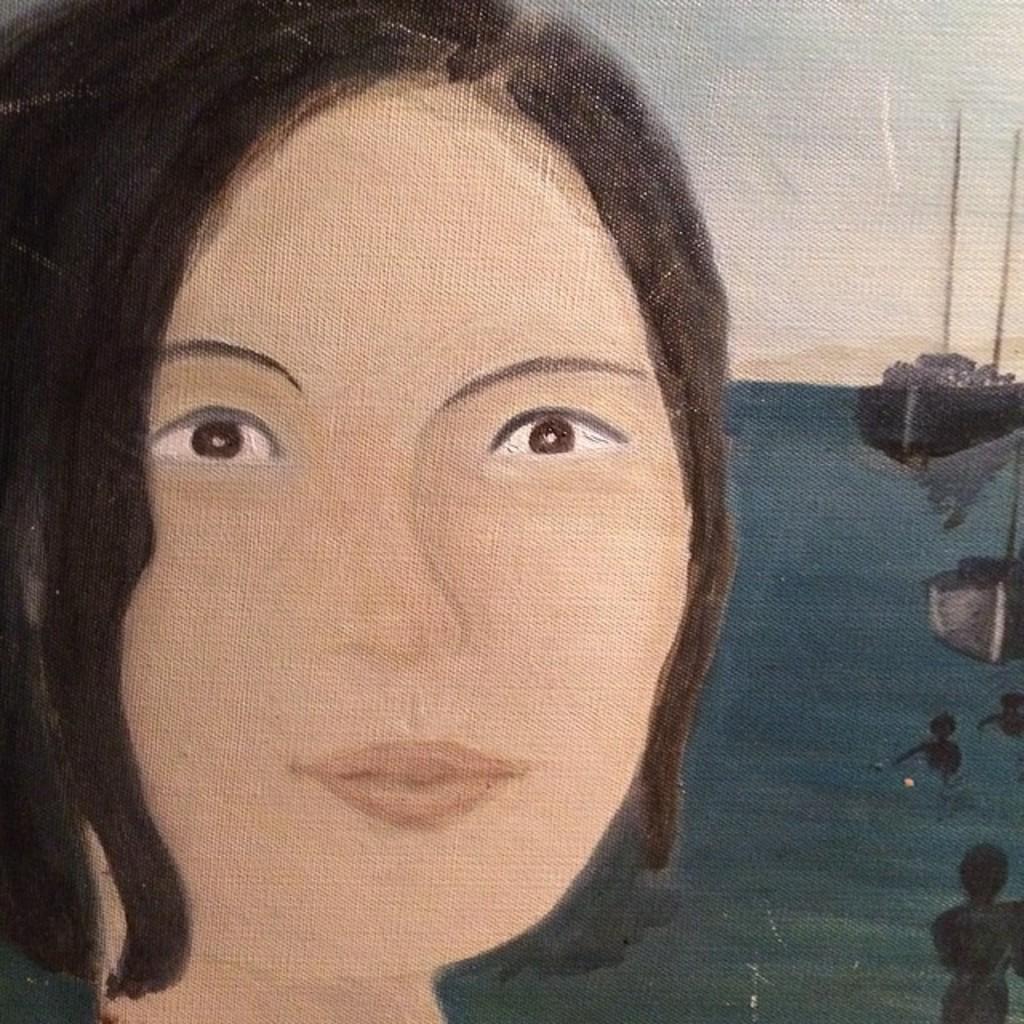Please provide a concise description of this image. In this image we can see a painting of a lady, water, boat, and the sky. 